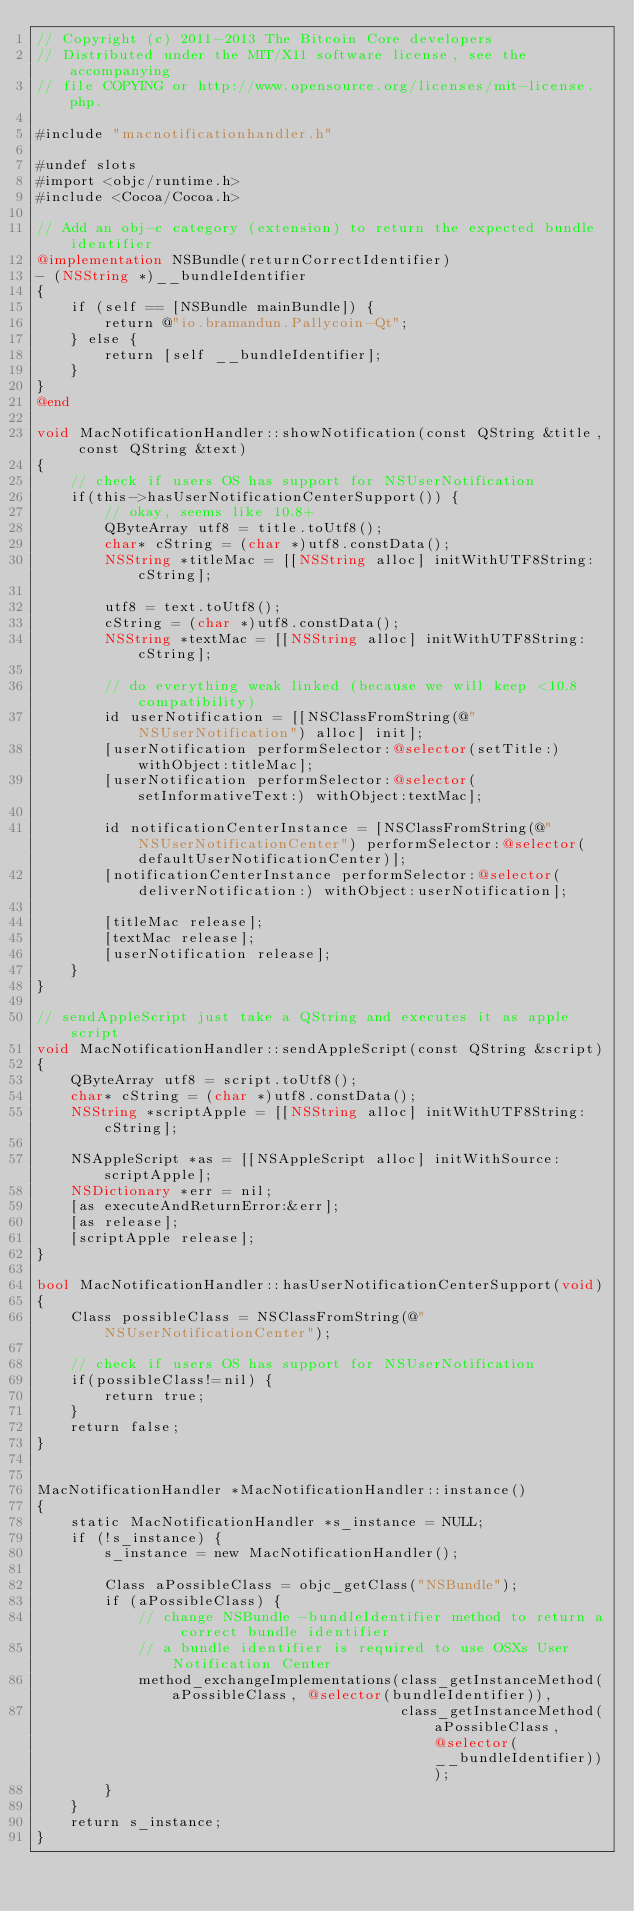<code> <loc_0><loc_0><loc_500><loc_500><_ObjectiveC_>// Copyright (c) 2011-2013 The Bitcoin Core developers
// Distributed under the MIT/X11 software license, see the accompanying
// file COPYING or http://www.opensource.org/licenses/mit-license.php.

#include "macnotificationhandler.h"

#undef slots
#import <objc/runtime.h>
#include <Cocoa/Cocoa.h>

// Add an obj-c category (extension) to return the expected bundle identifier
@implementation NSBundle(returnCorrectIdentifier)
- (NSString *)__bundleIdentifier
{
    if (self == [NSBundle mainBundle]) {
        return @"io.bramandun.Pallycoin-Qt";
    } else {
        return [self __bundleIdentifier];
    }
}
@end

void MacNotificationHandler::showNotification(const QString &title, const QString &text)
{
    // check if users OS has support for NSUserNotification
    if(this->hasUserNotificationCenterSupport()) {
        // okay, seems like 10.8+
        QByteArray utf8 = title.toUtf8();
        char* cString = (char *)utf8.constData();
        NSString *titleMac = [[NSString alloc] initWithUTF8String:cString];

        utf8 = text.toUtf8();
        cString = (char *)utf8.constData();
        NSString *textMac = [[NSString alloc] initWithUTF8String:cString];

        // do everything weak linked (because we will keep <10.8 compatibility)
        id userNotification = [[NSClassFromString(@"NSUserNotification") alloc] init];
        [userNotification performSelector:@selector(setTitle:) withObject:titleMac];
        [userNotification performSelector:@selector(setInformativeText:) withObject:textMac];

        id notificationCenterInstance = [NSClassFromString(@"NSUserNotificationCenter") performSelector:@selector(defaultUserNotificationCenter)];
        [notificationCenterInstance performSelector:@selector(deliverNotification:) withObject:userNotification];

        [titleMac release];
        [textMac release];
        [userNotification release];
    }
}

// sendAppleScript just take a QString and executes it as apple script
void MacNotificationHandler::sendAppleScript(const QString &script)
{
    QByteArray utf8 = script.toUtf8();
    char* cString = (char *)utf8.constData();
    NSString *scriptApple = [[NSString alloc] initWithUTF8String:cString];

    NSAppleScript *as = [[NSAppleScript alloc] initWithSource:scriptApple];
    NSDictionary *err = nil;
    [as executeAndReturnError:&err];
    [as release];
    [scriptApple release];
}

bool MacNotificationHandler::hasUserNotificationCenterSupport(void)
{
    Class possibleClass = NSClassFromString(@"NSUserNotificationCenter");

    // check if users OS has support for NSUserNotification
    if(possibleClass!=nil) {
        return true;
    }
    return false;
}


MacNotificationHandler *MacNotificationHandler::instance()
{
    static MacNotificationHandler *s_instance = NULL;
    if (!s_instance) {
        s_instance = new MacNotificationHandler();
        
        Class aPossibleClass = objc_getClass("NSBundle");
        if (aPossibleClass) {
            // change NSBundle -bundleIdentifier method to return a correct bundle identifier
            // a bundle identifier is required to use OSXs User Notification Center
            method_exchangeImplementations(class_getInstanceMethod(aPossibleClass, @selector(bundleIdentifier)),
                                           class_getInstanceMethod(aPossibleClass, @selector(__bundleIdentifier)));
        }
    }
    return s_instance;
}
</code> 